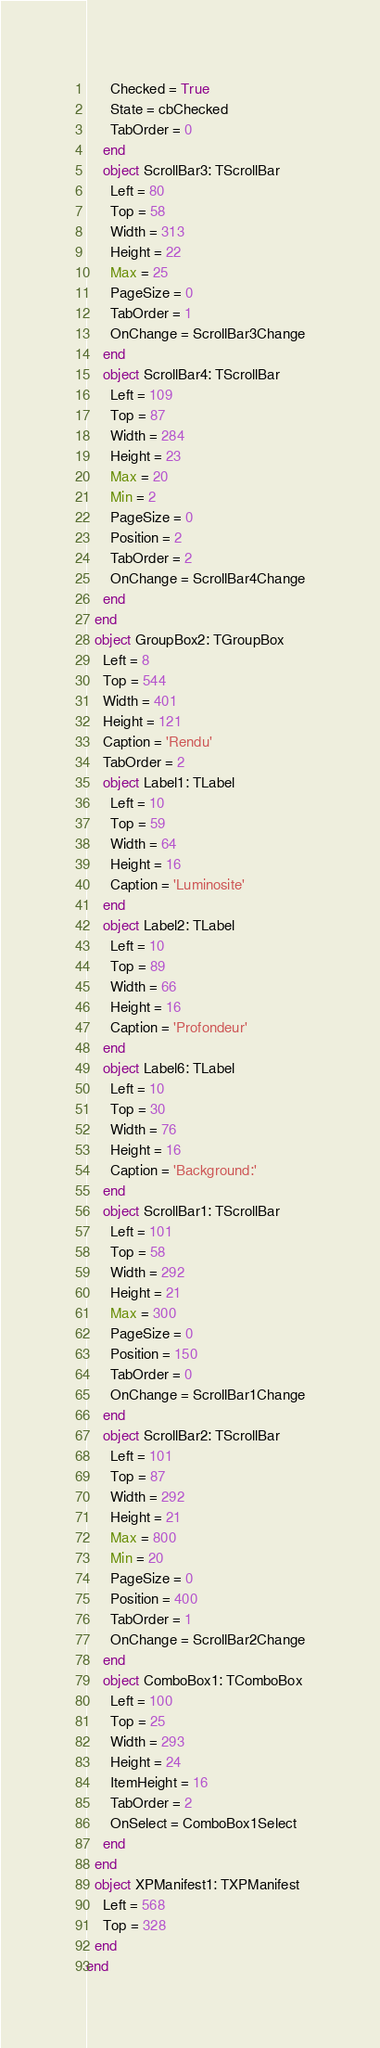Convert code to text. <code><loc_0><loc_0><loc_500><loc_500><_Pascal_>      Checked = True
      State = cbChecked
      TabOrder = 0
    end
    object ScrollBar3: TScrollBar
      Left = 80
      Top = 58
      Width = 313
      Height = 22
      Max = 25
      PageSize = 0
      TabOrder = 1
      OnChange = ScrollBar3Change
    end
    object ScrollBar4: TScrollBar
      Left = 109
      Top = 87
      Width = 284
      Height = 23
      Max = 20
      Min = 2
      PageSize = 0
      Position = 2
      TabOrder = 2
      OnChange = ScrollBar4Change
    end
  end
  object GroupBox2: TGroupBox
    Left = 8
    Top = 544
    Width = 401
    Height = 121
    Caption = 'Rendu'
    TabOrder = 2
    object Label1: TLabel
      Left = 10
      Top = 59
      Width = 64
      Height = 16
      Caption = 'Luminosite'
    end
    object Label2: TLabel
      Left = 10
      Top = 89
      Width = 66
      Height = 16
      Caption = 'Profondeur'
    end
    object Label6: TLabel
      Left = 10
      Top = 30
      Width = 76
      Height = 16
      Caption = 'Background:'
    end
    object ScrollBar1: TScrollBar
      Left = 101
      Top = 58
      Width = 292
      Height = 21
      Max = 300
      PageSize = 0
      Position = 150
      TabOrder = 0
      OnChange = ScrollBar1Change
    end
    object ScrollBar2: TScrollBar
      Left = 101
      Top = 87
      Width = 292
      Height = 21
      Max = 800
      Min = 20
      PageSize = 0
      Position = 400
      TabOrder = 1
      OnChange = ScrollBar2Change
    end
    object ComboBox1: TComboBox
      Left = 100
      Top = 25
      Width = 293
      Height = 24
      ItemHeight = 16
      TabOrder = 2
      OnSelect = ComboBox1Select
    end
  end
  object XPManifest1: TXPManifest
    Left = 568
    Top = 328
  end
end
</code> 